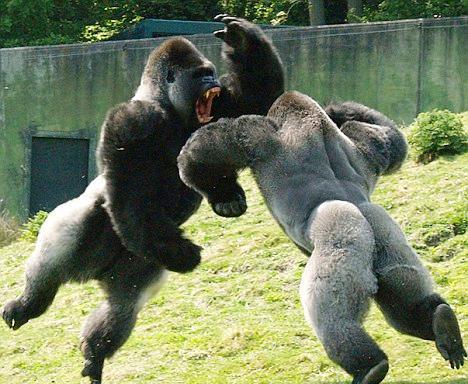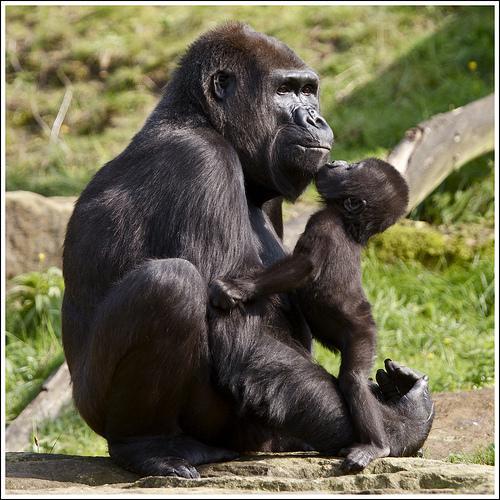The first image is the image on the left, the second image is the image on the right. Analyze the images presented: Is the assertion "A baby monkey is riding on an adult in the image on the right." valid? Answer yes or no. No. 